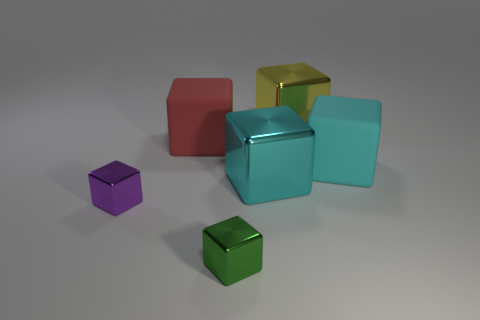Subtract all cyan blocks. How many blocks are left? 4 Subtract all green blocks. How many blocks are left? 5 Subtract all green blocks. Subtract all purple cylinders. How many blocks are left? 5 Add 1 small green matte cylinders. How many objects exist? 7 Subtract 0 gray blocks. How many objects are left? 6 Subtract all rubber cylinders. Subtract all shiny things. How many objects are left? 2 Add 5 large red things. How many large red things are left? 6 Add 3 big red rubber blocks. How many big red rubber blocks exist? 4 